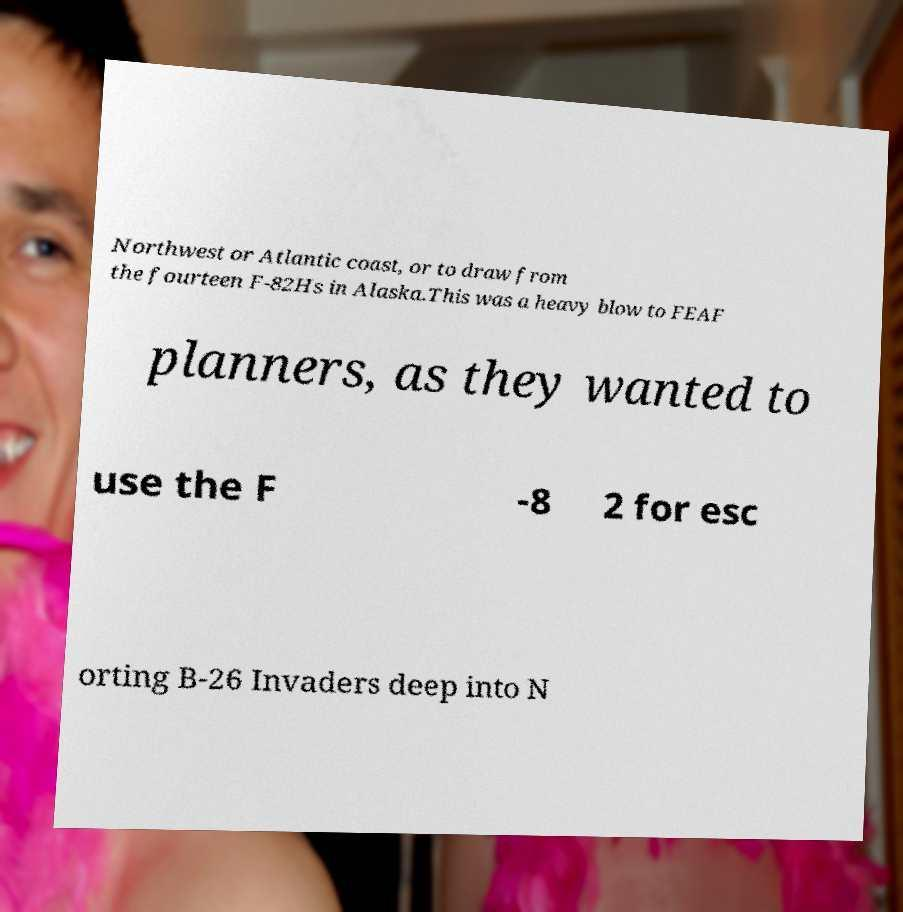I need the written content from this picture converted into text. Can you do that? Northwest or Atlantic coast, or to draw from the fourteen F-82Hs in Alaska.This was a heavy blow to FEAF planners, as they wanted to use the F -8 2 for esc orting B-26 Invaders deep into N 